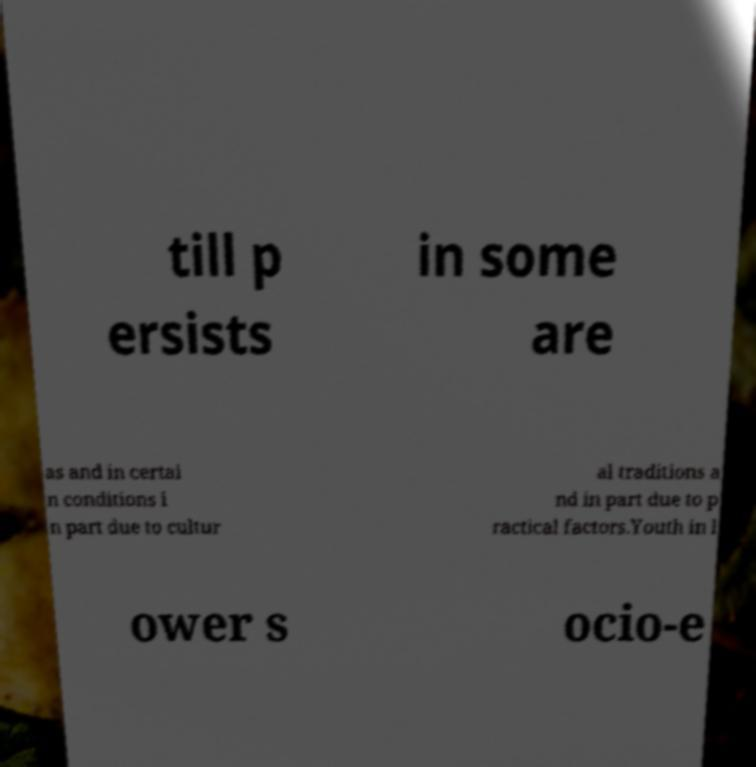Can you read and provide the text displayed in the image?This photo seems to have some interesting text. Can you extract and type it out for me? till p ersists in some are as and in certai n conditions i n part due to cultur al traditions a nd in part due to p ractical factors.Youth in l ower s ocio-e 